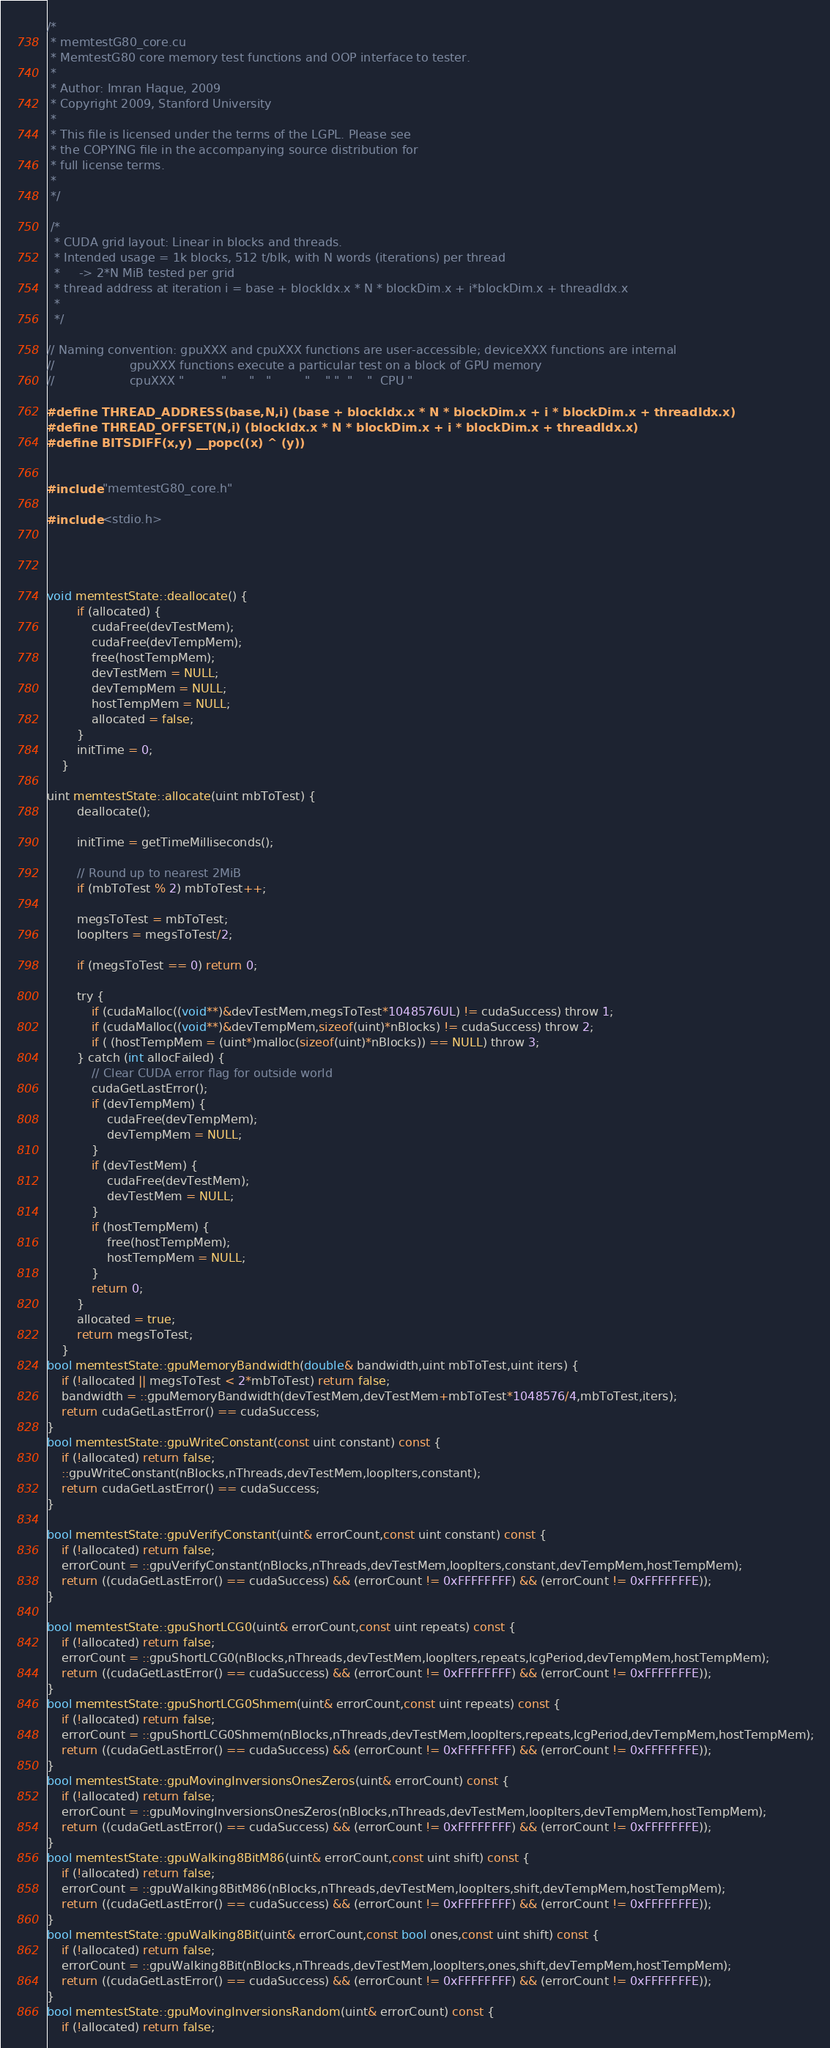Convert code to text. <code><loc_0><loc_0><loc_500><loc_500><_Cuda_>/*
 * memtestG80_core.cu
 * MemtestG80 core memory test functions and OOP interface to tester.
 *
 * Author: Imran Haque, 2009
 * Copyright 2009, Stanford University
 *
 * This file is licensed under the terms of the LGPL. Please see
 * the COPYING file in the accompanying source distribution for
 * full license terms.
 *
 */

 /*
  * CUDA grid layout: Linear in blocks and threads.
  * Intended usage = 1k blocks, 512 t/blk, with N words (iterations) per thread
  *     -> 2*N MiB tested per grid
  * thread address at iteration i = base + blockIdx.x * N * blockDim.x + i*blockDim.x + threadIdx.x
  *
  */

// Naming convention: gpuXXX and cpuXXX functions are user-accessible; deviceXXX functions are internal
//                    gpuXXX functions execute a particular test on a block of GPU memory
//                    cpuXXX "          "      "   "         "    " "  "    "  CPU "

#define THREAD_ADDRESS(base,N,i) (base + blockIdx.x * N * blockDim.x + i * blockDim.x + threadIdx.x)
#define THREAD_OFFSET(N,i) (blockIdx.x * N * blockDim.x + i * blockDim.x + threadIdx.x)
#define BITSDIFF(x,y) __popc((x) ^ (y))


#include "memtestG80_core.h"

#include <stdio.h>




void memtestState::deallocate() {
		if (allocated) {
			cudaFree(devTestMem);
			cudaFree(devTempMem);
			free(hostTempMem);
			devTestMem = NULL;
			devTempMem = NULL;
			hostTempMem = NULL;
			allocated = false;
		}
        initTime = 0;
	}

uint memtestState::allocate(uint mbToTest) {
		deallocate();

        initTime = getTimeMilliseconds();
		
        // Round up to nearest 2MiB
		if (mbToTest % 2) mbToTest++;

		megsToTest = mbToTest;
		loopIters = megsToTest/2;

		if (megsToTest == 0) return 0;
		
		try {
			if (cudaMalloc((void**)&devTestMem,megsToTest*1048576UL) != cudaSuccess) throw 1;
			if (cudaMalloc((void**)&devTempMem,sizeof(uint)*nBlocks) != cudaSuccess) throw 2;
			if ( (hostTempMem = (uint*)malloc(sizeof(uint)*nBlocks)) == NULL) throw 3;
		} catch (int allocFailed) {
            // Clear CUDA error flag for outside world
            cudaGetLastError();
			if (devTempMem) {
				cudaFree(devTempMem);
				devTempMem = NULL;
			}
			if (devTestMem) {
				cudaFree(devTestMem);
				devTestMem = NULL;
			}
			if (hostTempMem) {
				free(hostTempMem);
				hostTempMem = NULL;
			}
			return 0;
		}
		allocated = true;
		return megsToTest;
	}
bool memtestState::gpuMemoryBandwidth(double& bandwidth,uint mbToTest,uint iters) {
    if (!allocated || megsToTest < 2*mbToTest) return false;
    bandwidth = ::gpuMemoryBandwidth(devTestMem,devTestMem+mbToTest*1048576/4,mbToTest,iters);
    return cudaGetLastError() == cudaSuccess;
}
bool memtestState::gpuWriteConstant(const uint constant) const {
	if (!allocated) return false;
	::gpuWriteConstant(nBlocks,nThreads,devTestMem,loopIters,constant);
	return cudaGetLastError() == cudaSuccess;
}

bool memtestState::gpuVerifyConstant(uint& errorCount,const uint constant) const {
	if (!allocated) return false;
	errorCount = ::gpuVerifyConstant(nBlocks,nThreads,devTestMem,loopIters,constant,devTempMem,hostTempMem);
	return ((cudaGetLastError() == cudaSuccess) && (errorCount != 0xFFFFFFFF) && (errorCount != 0xFFFFFFFE));
}

bool memtestState::gpuShortLCG0(uint& errorCount,const uint repeats) const {
	if (!allocated) return false;
	errorCount = ::gpuShortLCG0(nBlocks,nThreads,devTestMem,loopIters,repeats,lcgPeriod,devTempMem,hostTempMem);
	return ((cudaGetLastError() == cudaSuccess) && (errorCount != 0xFFFFFFFF) && (errorCount != 0xFFFFFFFE));
}
bool memtestState::gpuShortLCG0Shmem(uint& errorCount,const uint repeats) const {
	if (!allocated) return false;
	errorCount = ::gpuShortLCG0Shmem(nBlocks,nThreads,devTestMem,loopIters,repeats,lcgPeriod,devTempMem,hostTempMem);
	return ((cudaGetLastError() == cudaSuccess) && (errorCount != 0xFFFFFFFF) && (errorCount != 0xFFFFFFFE));
}
bool memtestState::gpuMovingInversionsOnesZeros(uint& errorCount) const {
	if (!allocated) return false;
	errorCount = ::gpuMovingInversionsOnesZeros(nBlocks,nThreads,devTestMem,loopIters,devTempMem,hostTempMem);
	return ((cudaGetLastError() == cudaSuccess) && (errorCount != 0xFFFFFFFF) && (errorCount != 0xFFFFFFFE));
}
bool memtestState::gpuWalking8BitM86(uint& errorCount,const uint shift) const {
	if (!allocated) return false;
	errorCount = ::gpuWalking8BitM86(nBlocks,nThreads,devTestMem,loopIters,shift,devTempMem,hostTempMem);
	return ((cudaGetLastError() == cudaSuccess) && (errorCount != 0xFFFFFFFF) && (errorCount != 0xFFFFFFFE));
}
bool memtestState::gpuWalking8Bit(uint& errorCount,const bool ones,const uint shift) const {
	if (!allocated) return false;
	errorCount = ::gpuWalking8Bit(nBlocks,nThreads,devTestMem,loopIters,ones,shift,devTempMem,hostTempMem);
	return ((cudaGetLastError() == cudaSuccess) && (errorCount != 0xFFFFFFFF) && (errorCount != 0xFFFFFFFE));
}
bool memtestState::gpuMovingInversionsRandom(uint& errorCount) const {
	if (!allocated) return false;</code> 